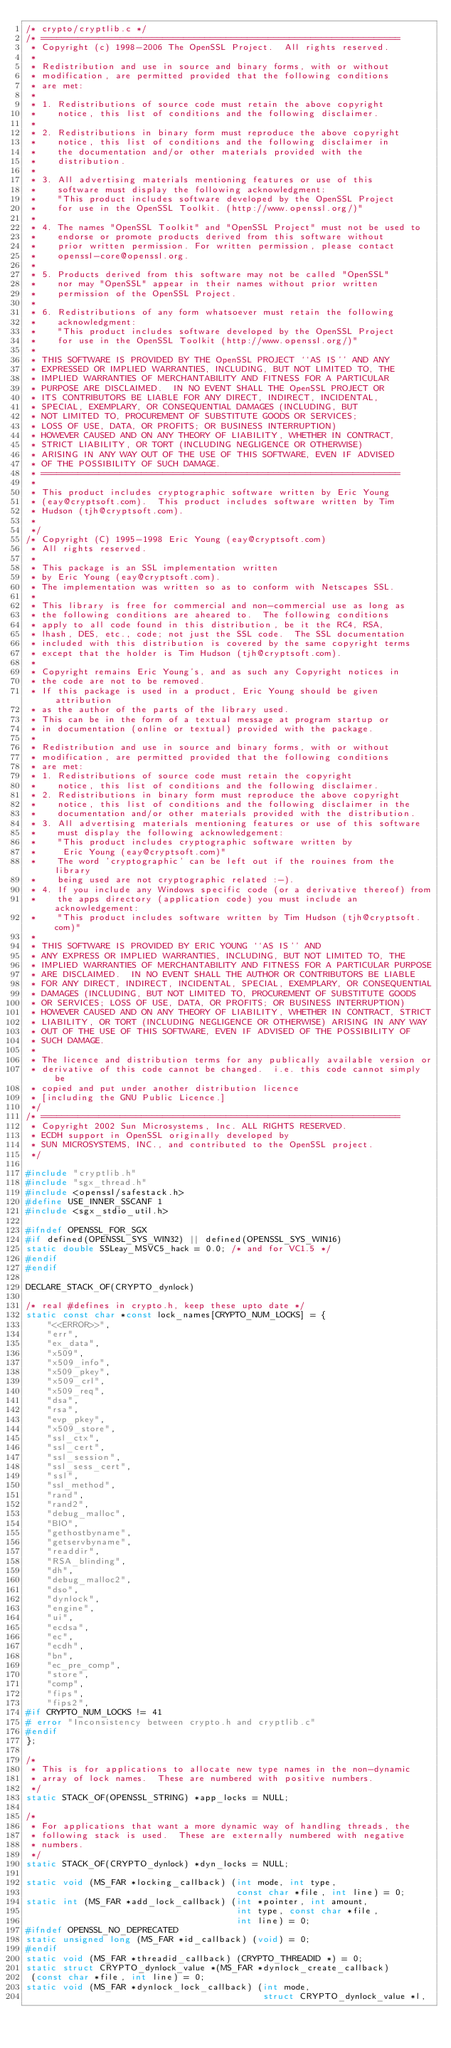Convert code to text. <code><loc_0><loc_0><loc_500><loc_500><_C_>/* crypto/cryptlib.c */
/* ====================================================================
 * Copyright (c) 1998-2006 The OpenSSL Project.  All rights reserved.
 *
 * Redistribution and use in source and binary forms, with or without
 * modification, are permitted provided that the following conditions
 * are met:
 *
 * 1. Redistributions of source code must retain the above copyright
 *    notice, this list of conditions and the following disclaimer.
 *
 * 2. Redistributions in binary form must reproduce the above copyright
 *    notice, this list of conditions and the following disclaimer in
 *    the documentation and/or other materials provided with the
 *    distribution.
 *
 * 3. All advertising materials mentioning features or use of this
 *    software must display the following acknowledgment:
 *    "This product includes software developed by the OpenSSL Project
 *    for use in the OpenSSL Toolkit. (http://www.openssl.org/)"
 *
 * 4. The names "OpenSSL Toolkit" and "OpenSSL Project" must not be used to
 *    endorse or promote products derived from this software without
 *    prior written permission. For written permission, please contact
 *    openssl-core@openssl.org.
 *
 * 5. Products derived from this software may not be called "OpenSSL"
 *    nor may "OpenSSL" appear in their names without prior written
 *    permission of the OpenSSL Project.
 *
 * 6. Redistributions of any form whatsoever must retain the following
 *    acknowledgment:
 *    "This product includes software developed by the OpenSSL Project
 *    for use in the OpenSSL Toolkit (http://www.openssl.org/)"
 *
 * THIS SOFTWARE IS PROVIDED BY THE OpenSSL PROJECT ``AS IS'' AND ANY
 * EXPRESSED OR IMPLIED WARRANTIES, INCLUDING, BUT NOT LIMITED TO, THE
 * IMPLIED WARRANTIES OF MERCHANTABILITY AND FITNESS FOR A PARTICULAR
 * PURPOSE ARE DISCLAIMED.  IN NO EVENT SHALL THE OpenSSL PROJECT OR
 * ITS CONTRIBUTORS BE LIABLE FOR ANY DIRECT, INDIRECT, INCIDENTAL,
 * SPECIAL, EXEMPLARY, OR CONSEQUENTIAL DAMAGES (INCLUDING, BUT
 * NOT LIMITED TO, PROCUREMENT OF SUBSTITUTE GOODS OR SERVICES;
 * LOSS OF USE, DATA, OR PROFITS; OR BUSINESS INTERRUPTION)
 * HOWEVER CAUSED AND ON ANY THEORY OF LIABILITY, WHETHER IN CONTRACT,
 * STRICT LIABILITY, OR TORT (INCLUDING NEGLIGENCE OR OTHERWISE)
 * ARISING IN ANY WAY OUT OF THE USE OF THIS SOFTWARE, EVEN IF ADVISED
 * OF THE POSSIBILITY OF SUCH DAMAGE.
 * ====================================================================
 *
 * This product includes cryptographic software written by Eric Young
 * (eay@cryptsoft.com).  This product includes software written by Tim
 * Hudson (tjh@cryptsoft.com).
 *
 */
/* Copyright (C) 1995-1998 Eric Young (eay@cryptsoft.com)
 * All rights reserved.
 *
 * This package is an SSL implementation written
 * by Eric Young (eay@cryptsoft.com).
 * The implementation was written so as to conform with Netscapes SSL.
 *
 * This library is free for commercial and non-commercial use as long as
 * the following conditions are aheared to.  The following conditions
 * apply to all code found in this distribution, be it the RC4, RSA,
 * lhash, DES, etc., code; not just the SSL code.  The SSL documentation
 * included with this distribution is covered by the same copyright terms
 * except that the holder is Tim Hudson (tjh@cryptsoft.com).
 *
 * Copyright remains Eric Young's, and as such any Copyright notices in
 * the code are not to be removed.
 * If this package is used in a product, Eric Young should be given attribution
 * as the author of the parts of the library used.
 * This can be in the form of a textual message at program startup or
 * in documentation (online or textual) provided with the package.
 *
 * Redistribution and use in source and binary forms, with or without
 * modification, are permitted provided that the following conditions
 * are met:
 * 1. Redistributions of source code must retain the copyright
 *    notice, this list of conditions and the following disclaimer.
 * 2. Redistributions in binary form must reproduce the above copyright
 *    notice, this list of conditions and the following disclaimer in the
 *    documentation and/or other materials provided with the distribution.
 * 3. All advertising materials mentioning features or use of this software
 *    must display the following acknowledgement:
 *    "This product includes cryptographic software written by
 *     Eric Young (eay@cryptsoft.com)"
 *    The word 'cryptographic' can be left out if the rouines from the library
 *    being used are not cryptographic related :-).
 * 4. If you include any Windows specific code (or a derivative thereof) from
 *    the apps directory (application code) you must include an acknowledgement:
 *    "This product includes software written by Tim Hudson (tjh@cryptsoft.com)"
 *
 * THIS SOFTWARE IS PROVIDED BY ERIC YOUNG ``AS IS'' AND
 * ANY EXPRESS OR IMPLIED WARRANTIES, INCLUDING, BUT NOT LIMITED TO, THE
 * IMPLIED WARRANTIES OF MERCHANTABILITY AND FITNESS FOR A PARTICULAR PURPOSE
 * ARE DISCLAIMED.  IN NO EVENT SHALL THE AUTHOR OR CONTRIBUTORS BE LIABLE
 * FOR ANY DIRECT, INDIRECT, INCIDENTAL, SPECIAL, EXEMPLARY, OR CONSEQUENTIAL
 * DAMAGES (INCLUDING, BUT NOT LIMITED TO, PROCUREMENT OF SUBSTITUTE GOODS
 * OR SERVICES; LOSS OF USE, DATA, OR PROFITS; OR BUSINESS INTERRUPTION)
 * HOWEVER CAUSED AND ON ANY THEORY OF LIABILITY, WHETHER IN CONTRACT, STRICT
 * LIABILITY, OR TORT (INCLUDING NEGLIGENCE OR OTHERWISE) ARISING IN ANY WAY
 * OUT OF THE USE OF THIS SOFTWARE, EVEN IF ADVISED OF THE POSSIBILITY OF
 * SUCH DAMAGE.
 *
 * The licence and distribution terms for any publically available version or
 * derivative of this code cannot be changed.  i.e. this code cannot simply be
 * copied and put under another distribution licence
 * [including the GNU Public Licence.]
 */
/* ====================================================================
 * Copyright 2002 Sun Microsystems, Inc. ALL RIGHTS RESERVED.
 * ECDH support in OpenSSL originally developed by
 * SUN MICROSYSTEMS, INC., and contributed to the OpenSSL project.
 */

#include "cryptlib.h"
#include "sgx_thread.h"
#include <openssl/safestack.h>
#define USE_INNER_SSCANF 1
#include <sgx_stdio_util.h> 

#ifndef OPENSSL_FOR_SGX
#if defined(OPENSSL_SYS_WIN32) || defined(OPENSSL_SYS_WIN16)
static double SSLeay_MSVC5_hack = 0.0; /* and for VC1.5 */
#endif
#endif

DECLARE_STACK_OF(CRYPTO_dynlock)

/* real #defines in crypto.h, keep these upto date */
static const char *const lock_names[CRYPTO_NUM_LOCKS] = {
    "<<ERROR>>",
    "err",
    "ex_data",
    "x509",
    "x509_info",
    "x509_pkey",
    "x509_crl",
    "x509_req",
    "dsa",
    "rsa",
    "evp_pkey",
    "x509_store",
    "ssl_ctx",
    "ssl_cert",
    "ssl_session",
    "ssl_sess_cert",
    "ssl",
    "ssl_method",
    "rand",
    "rand2",
    "debug_malloc",
    "BIO",
    "gethostbyname",
    "getservbyname",
    "readdir",
    "RSA_blinding",
    "dh",
    "debug_malloc2",
    "dso",
    "dynlock",
    "engine",
    "ui",
    "ecdsa",
    "ec",
    "ecdh",
    "bn",
    "ec_pre_comp",
    "store",
    "comp",
    "fips",
    "fips2",
#if CRYPTO_NUM_LOCKS != 41
# error "Inconsistency between crypto.h and cryptlib.c"
#endif
};

/*
 * This is for applications to allocate new type names in the non-dynamic
 * array of lock names.  These are numbered with positive numbers.
 */
static STACK_OF(OPENSSL_STRING) *app_locks = NULL;

/*
 * For applications that want a more dynamic way of handling threads, the
 * following stack is used.  These are externally numbered with negative
 * numbers.
 */
static STACK_OF(CRYPTO_dynlock) *dyn_locks = NULL;

static void (MS_FAR *locking_callback) (int mode, int type,
                                        const char *file, int line) = 0;
static int (MS_FAR *add_lock_callback) (int *pointer, int amount,
                                        int type, const char *file,
                                        int line) = 0;
#ifndef OPENSSL_NO_DEPRECATED
static unsigned long (MS_FAR *id_callback) (void) = 0;
#endif
static void (MS_FAR *threadid_callback) (CRYPTO_THREADID *) = 0;
static struct CRYPTO_dynlock_value *(MS_FAR *dynlock_create_callback)
 (const char *file, int line) = 0;
static void (MS_FAR *dynlock_lock_callback) (int mode,
                                             struct CRYPTO_dynlock_value *l,</code> 